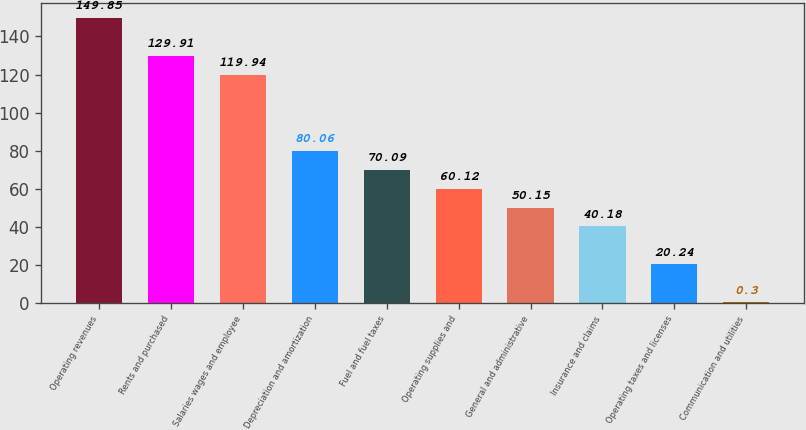<chart> <loc_0><loc_0><loc_500><loc_500><bar_chart><fcel>Operating revenues<fcel>Rents and purchased<fcel>Salaries wages and employee<fcel>Depreciation and amortization<fcel>Fuel and fuel taxes<fcel>Operating supplies and<fcel>General and administrative<fcel>Insurance and claims<fcel>Operating taxes and licenses<fcel>Communication and utilities<nl><fcel>149.85<fcel>129.91<fcel>119.94<fcel>80.06<fcel>70.09<fcel>60.12<fcel>50.15<fcel>40.18<fcel>20.24<fcel>0.3<nl></chart> 